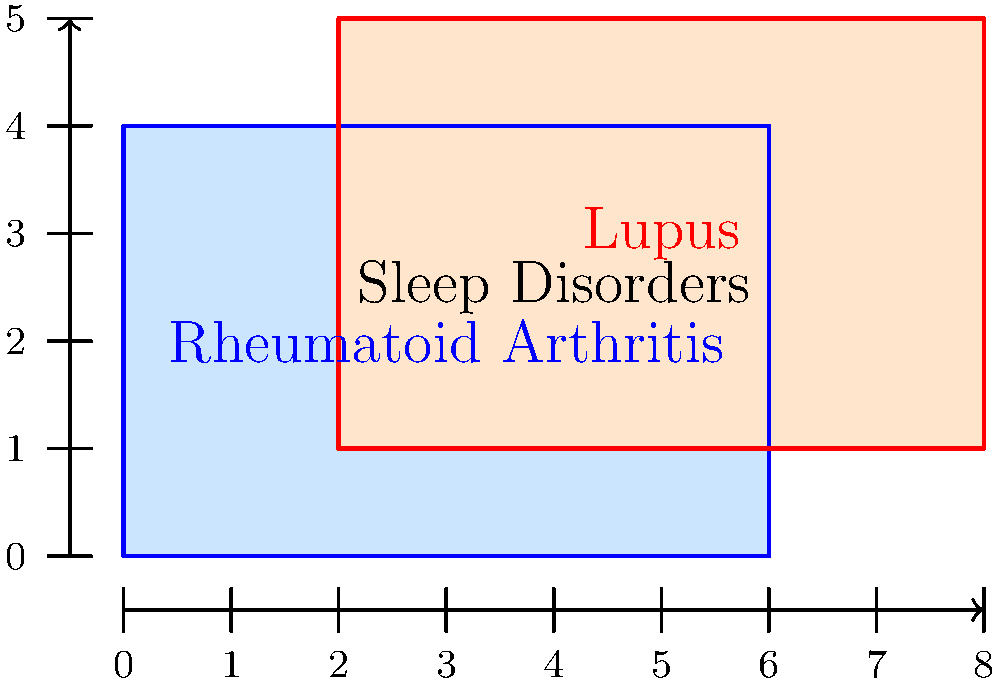In a study of autoimmune diseases and sleep disorders, the diagram represents the prevalence of rheumatoid arthritis (blue rectangle) and lupus (red rectangle) in a patient population. The overlapping area represents patients with both conditions who also experience sleep disorders. If each unit on the grid represents 100 patients, what is the total number of patients with sleep disorders in this population? To solve this problem, we need to calculate the area of the overlapping region between the two rectangles. Let's break it down step by step:

1. Identify the coordinates of the overlapping region:
   - Left edge: x = 2
   - Right edge: x = 6
   - Bottom edge: y = 1
   - Top edge: y = 4

2. Calculate the dimensions of the overlapping region:
   - Width = 6 - 2 = 4 units
   - Height = 4 - 1 = 3 units

3. Calculate the area of the overlapping region:
   $$ \text{Area} = \text{Width} \times \text{Height} = 4 \times 3 = 12 \text{ square units} $$

4. Convert square units to number of patients:
   Each unit represents 100 patients, so:
   $$ \text{Number of patients} = 12 \times 100 = 1,200 \text{ patients} $$

Therefore, the total number of patients with sleep disorders (represented by the overlapping area) is 1,200.
Answer: 1,200 patients 